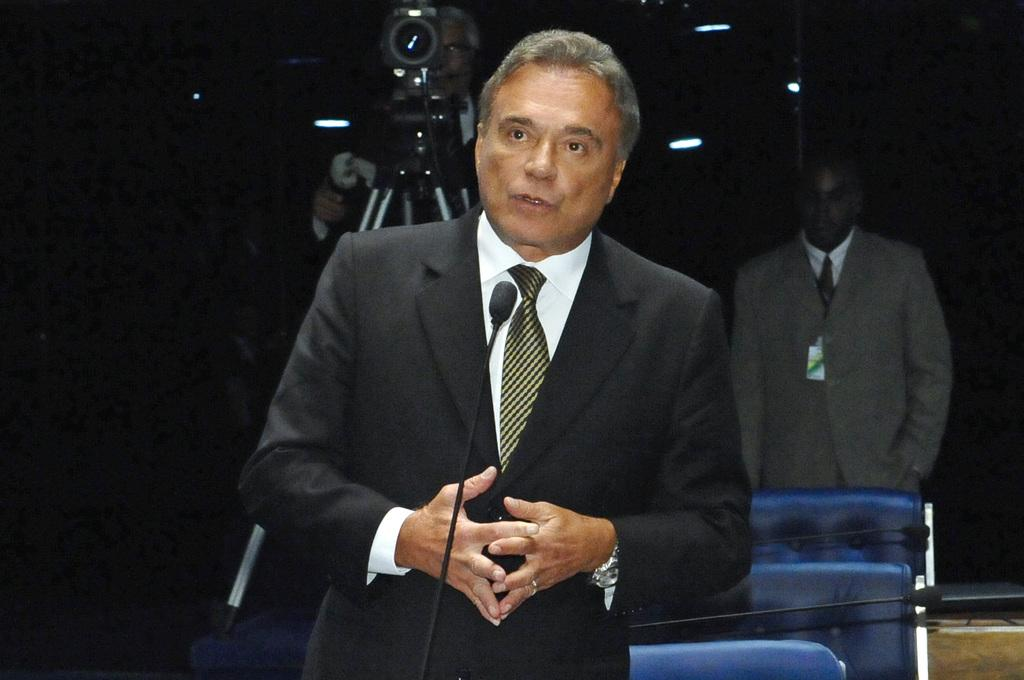What is the person wearing in the image? The person is wearing a watch. What object is in front of the person? There is a microphone in front of the person. What can be seen in the background of the image? There are chairs in the background. What is the position of the second person in the image? There is a person standing. What is the person holding in the image? Another person is holding a camera with a stand. Can you see any geese on the coast in the image? There are no geese or coast visible in the image. Is there a gun present in the image? There is no gun present in the image. 